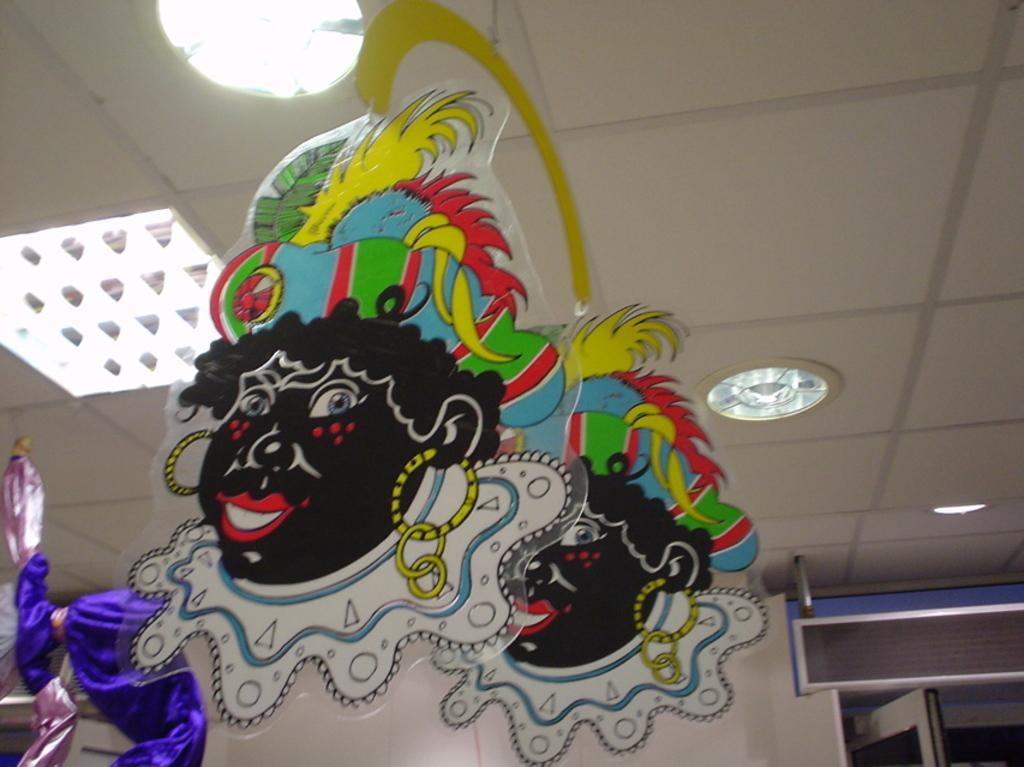What can be seen on the objects in the image? There are paintings on objects in the image. What is attached to the roof in the image? There are lights attached to the roof in the image. Where is the door located in the image? There is a door in the right bottom of the image. What is present in the left bottom of the image? There is an object in the left bottom of the image. What type of jail is depicted in the image? There is no jail present in the image. What material is the linen made of in the image? There is no linen present in the image. 